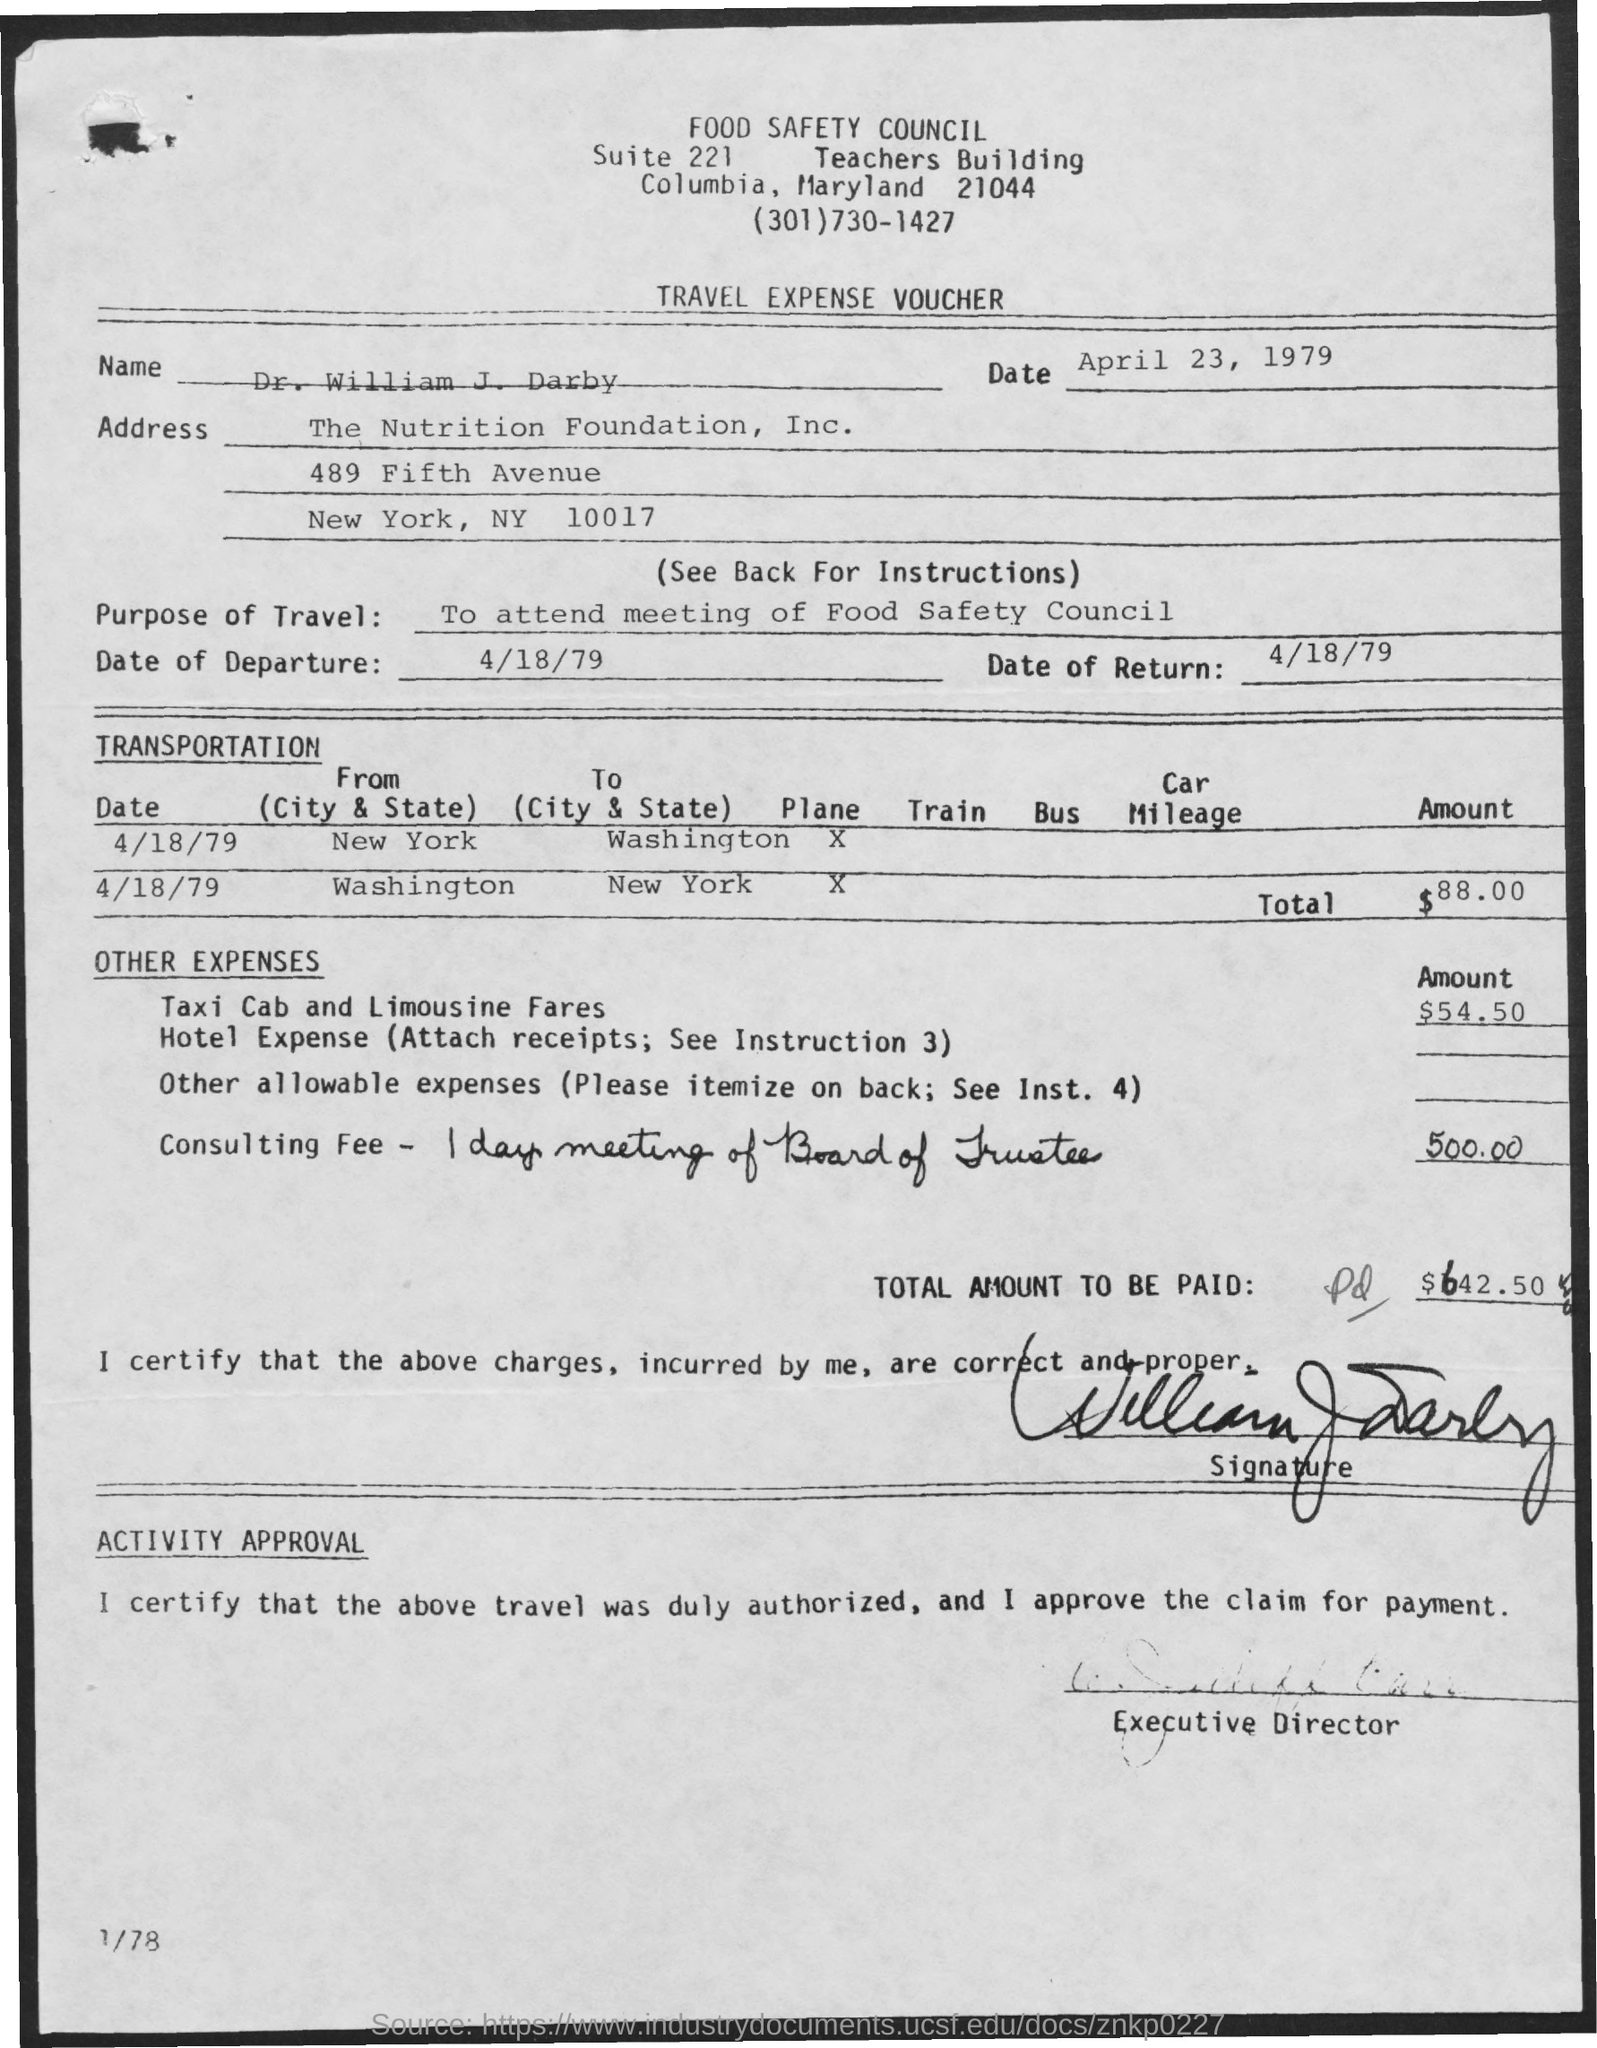What is the Return Date ? The return date documented on the travel expense voucher is April 18, 1979. 